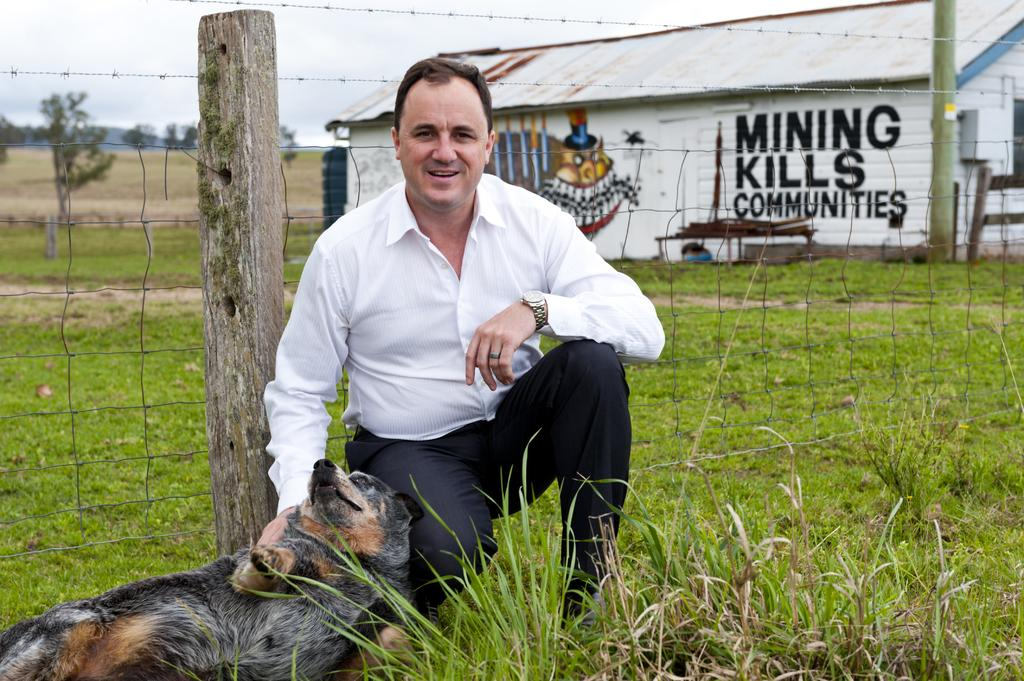Who is present in the image? There is a man in the image. What is the man doing in the image? The man is holding a dog in the image. Where is the man sitting in the image? The man is sitting in a garden in the image. What can be seen in the background of the image? There is a house and the sky visible in the background of the image. What type of enclosure surrounds the garden? There is fencing around the garden in the image. What activity is the mist participating in with the man and dog in the image? There is no mist present in the image, so it cannot participate in any activity with the man and dog. 